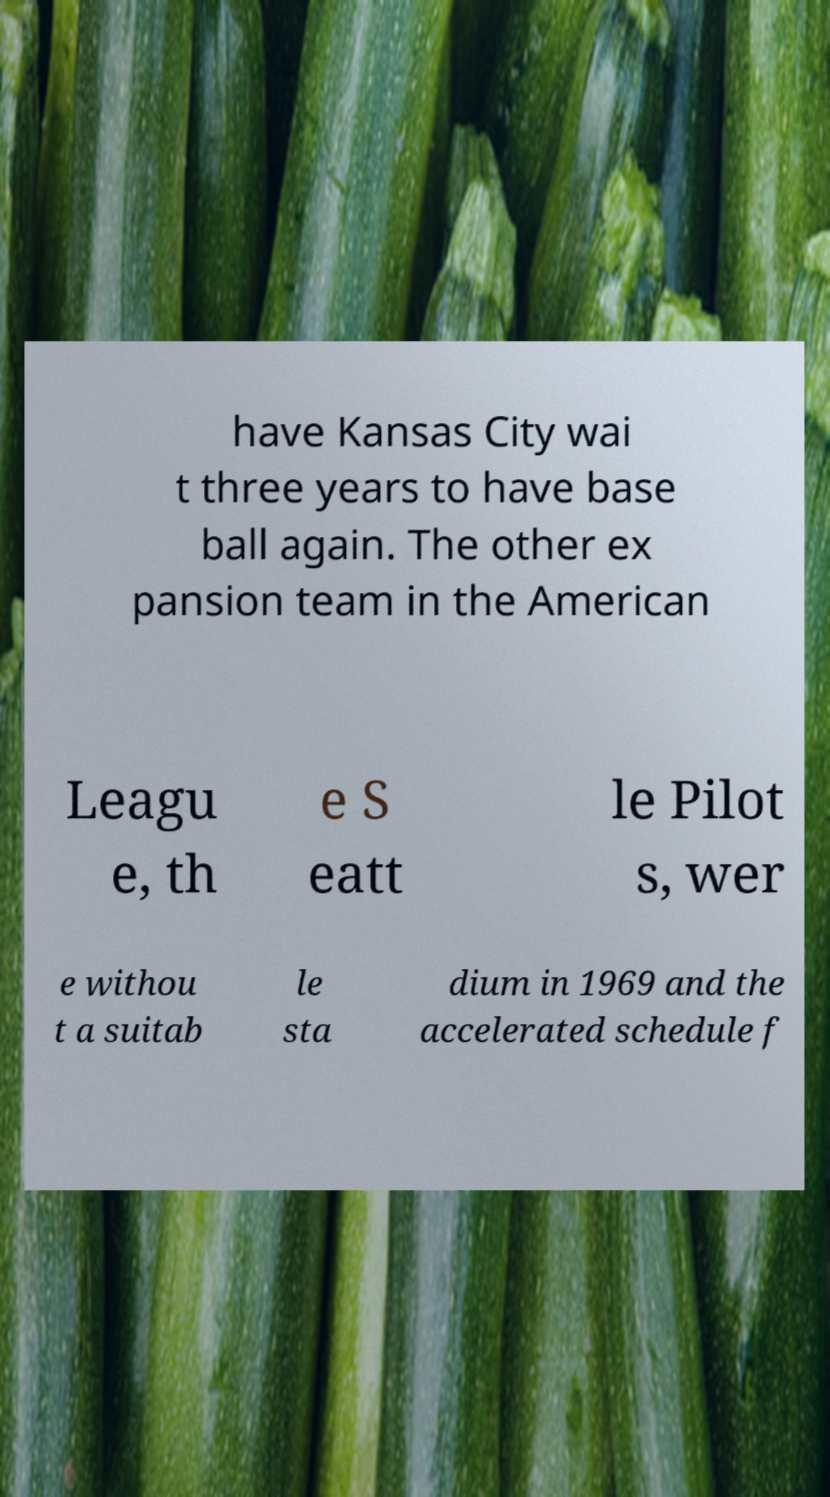Can you accurately transcribe the text from the provided image for me? have Kansas City wai t three years to have base ball again. The other ex pansion team in the American Leagu e, th e S eatt le Pilot s, wer e withou t a suitab le sta dium in 1969 and the accelerated schedule f 